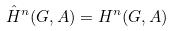<formula> <loc_0><loc_0><loc_500><loc_500>\hat { H } ^ { n } ( G , A ) = H ^ { n } ( G , A )</formula> 